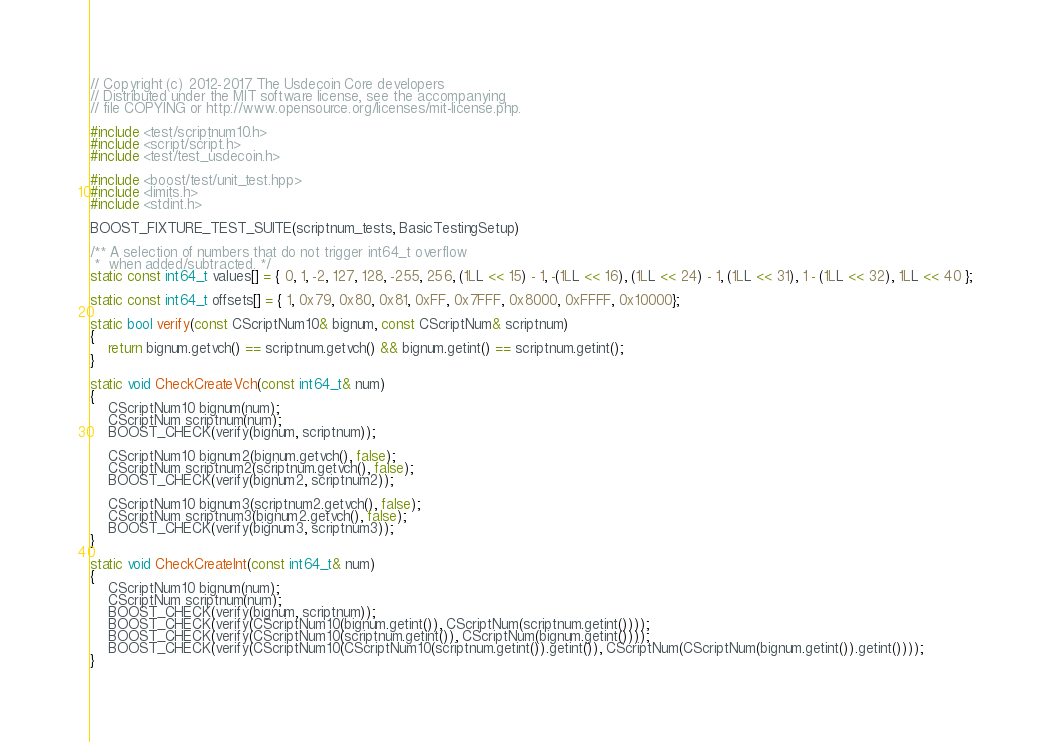Convert code to text. <code><loc_0><loc_0><loc_500><loc_500><_C++_>// Copyright (c) 2012-2017 The Usdecoin Core developers
// Distributed under the MIT software license, see the accompanying
// file COPYING or http://www.opensource.org/licenses/mit-license.php.

#include <test/scriptnum10.h>
#include <script/script.h>
#include <test/test_usdecoin.h>

#include <boost/test/unit_test.hpp>
#include <limits.h>
#include <stdint.h>

BOOST_FIXTURE_TEST_SUITE(scriptnum_tests, BasicTestingSetup)

/** A selection of numbers that do not trigger int64_t overflow
 *  when added/subtracted. */
static const int64_t values[] = { 0, 1, -2, 127, 128, -255, 256, (1LL << 15) - 1, -(1LL << 16), (1LL << 24) - 1, (1LL << 31), 1 - (1LL << 32), 1LL << 40 };

static const int64_t offsets[] = { 1, 0x79, 0x80, 0x81, 0xFF, 0x7FFF, 0x8000, 0xFFFF, 0x10000};

static bool verify(const CScriptNum10& bignum, const CScriptNum& scriptnum)
{
    return bignum.getvch() == scriptnum.getvch() && bignum.getint() == scriptnum.getint();
}

static void CheckCreateVch(const int64_t& num)
{
    CScriptNum10 bignum(num);
    CScriptNum scriptnum(num);
    BOOST_CHECK(verify(bignum, scriptnum));

    CScriptNum10 bignum2(bignum.getvch(), false);
    CScriptNum scriptnum2(scriptnum.getvch(), false);
    BOOST_CHECK(verify(bignum2, scriptnum2));

    CScriptNum10 bignum3(scriptnum2.getvch(), false);
    CScriptNum scriptnum3(bignum2.getvch(), false);
    BOOST_CHECK(verify(bignum3, scriptnum3));
}

static void CheckCreateInt(const int64_t& num)
{
    CScriptNum10 bignum(num);
    CScriptNum scriptnum(num);
    BOOST_CHECK(verify(bignum, scriptnum));
    BOOST_CHECK(verify(CScriptNum10(bignum.getint()), CScriptNum(scriptnum.getint())));
    BOOST_CHECK(verify(CScriptNum10(scriptnum.getint()), CScriptNum(bignum.getint())));
    BOOST_CHECK(verify(CScriptNum10(CScriptNum10(scriptnum.getint()).getint()), CScriptNum(CScriptNum(bignum.getint()).getint())));
}

</code> 